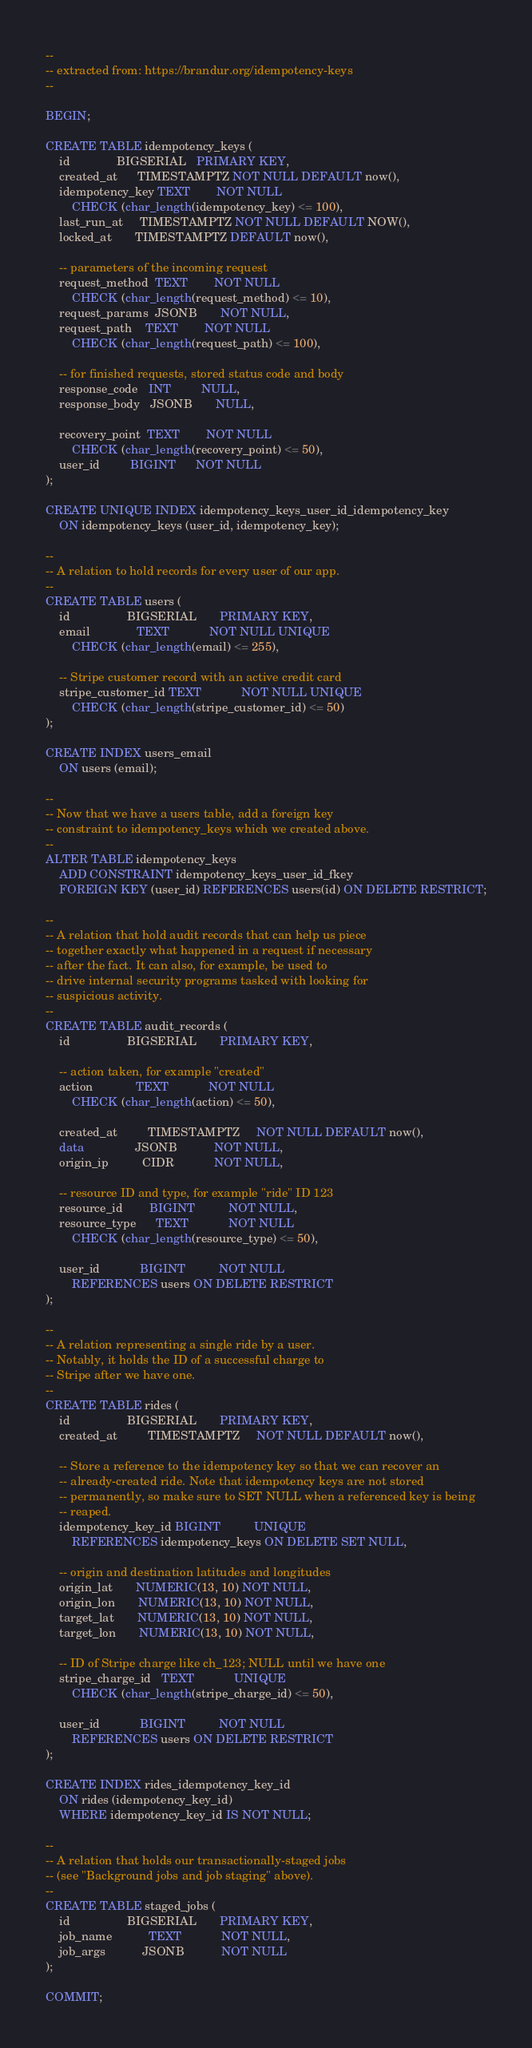Convert code to text. <code><loc_0><loc_0><loc_500><loc_500><_SQL_>--
-- extracted from: https://brandur.org/idempotency-keys
--

BEGIN;

CREATE TABLE idempotency_keys (
    id              BIGSERIAL   PRIMARY KEY,
    created_at      TIMESTAMPTZ NOT NULL DEFAULT now(),
    idempotency_key TEXT        NOT NULL
        CHECK (char_length(idempotency_key) <= 100),
    last_run_at     TIMESTAMPTZ NOT NULL DEFAULT NOW(),
    locked_at       TIMESTAMPTZ DEFAULT now(),

    -- parameters of the incoming request
    request_method  TEXT        NOT NULL
        CHECK (char_length(request_method) <= 10),
    request_params  JSONB       NOT NULL,
    request_path    TEXT        NOT NULL
        CHECK (char_length(request_path) <= 100),

    -- for finished requests, stored status code and body
    response_code   INT         NULL,
    response_body   JSONB       NULL,

    recovery_point  TEXT        NOT NULL
        CHECK (char_length(recovery_point) <= 50),
    user_id         BIGINT      NOT NULL
);

CREATE UNIQUE INDEX idempotency_keys_user_id_idempotency_key
    ON idempotency_keys (user_id, idempotency_key);

--
-- A relation to hold records for every user of our app.
--
CREATE TABLE users (
    id                 BIGSERIAL       PRIMARY KEY,
    email              TEXT            NOT NULL UNIQUE
        CHECK (char_length(email) <= 255),

    -- Stripe customer record with an active credit card
    stripe_customer_id TEXT            NOT NULL UNIQUE
        CHECK (char_length(stripe_customer_id) <= 50)
);

CREATE INDEX users_email
    ON users (email);

--
-- Now that we have a users table, add a foreign key
-- constraint to idempotency_keys which we created above.
--
ALTER TABLE idempotency_keys
    ADD CONSTRAINT idempotency_keys_user_id_fkey
    FOREIGN KEY (user_id) REFERENCES users(id) ON DELETE RESTRICT;

--
-- A relation that hold audit records that can help us piece
-- together exactly what happened in a request if necessary
-- after the fact. It can also, for example, be used to
-- drive internal security programs tasked with looking for
-- suspicious activity.
--
CREATE TABLE audit_records (
    id                 BIGSERIAL       PRIMARY KEY,

    -- action taken, for example "created"
    action             TEXT            NOT NULL
        CHECK (char_length(action) <= 50),

    created_at         TIMESTAMPTZ     NOT NULL DEFAULT now(),
    data               JSONB           NOT NULL,
    origin_ip          CIDR            NOT NULL,

    -- resource ID and type, for example "ride" ID 123
    resource_id        BIGINT          NOT NULL,
    resource_type      TEXT            NOT NULL
        CHECK (char_length(resource_type) <= 50),

    user_id            BIGINT          NOT NULL
        REFERENCES users ON DELETE RESTRICT
);

--
-- A relation representing a single ride by a user.
-- Notably, it holds the ID of a successful charge to
-- Stripe after we have one.
--
CREATE TABLE rides (
    id                 BIGSERIAL       PRIMARY KEY,
    created_at         TIMESTAMPTZ     NOT NULL DEFAULT now(),

    -- Store a reference to the idempotency key so that we can recover an
    -- already-created ride. Note that idempotency keys are not stored
    -- permanently, so make sure to SET NULL when a referenced key is being
    -- reaped.
    idempotency_key_id BIGINT          UNIQUE
        REFERENCES idempotency_keys ON DELETE SET NULL,

    -- origin and destination latitudes and longitudes
    origin_lat       NUMERIC(13, 10) NOT NULL,
    origin_lon       NUMERIC(13, 10) NOT NULL,
    target_lat       NUMERIC(13, 10) NOT NULL,
    target_lon       NUMERIC(13, 10) NOT NULL,

    -- ID of Stripe charge like ch_123; NULL until we have one
    stripe_charge_id   TEXT            UNIQUE
        CHECK (char_length(stripe_charge_id) <= 50),

    user_id            BIGINT          NOT NULL
        REFERENCES users ON DELETE RESTRICT
);

CREATE INDEX rides_idempotency_key_id
    ON rides (idempotency_key_id)
    WHERE idempotency_key_id IS NOT NULL;

--
-- A relation that holds our transactionally-staged jobs
-- (see "Background jobs and job staging" above).
--
CREATE TABLE staged_jobs (
    id                 BIGSERIAL       PRIMARY KEY,
    job_name           TEXT            NOT NULL,
    job_args           JSONB           NOT NULL
);

COMMIT;
</code> 